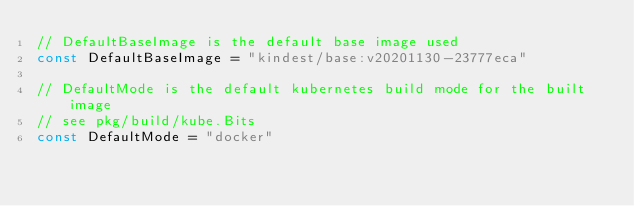<code> <loc_0><loc_0><loc_500><loc_500><_Go_>// DefaultBaseImage is the default base image used
const DefaultBaseImage = "kindest/base:v20201130-23777eca"

// DefaultMode is the default kubernetes build mode for the built image
// see pkg/build/kube.Bits
const DefaultMode = "docker"
</code> 